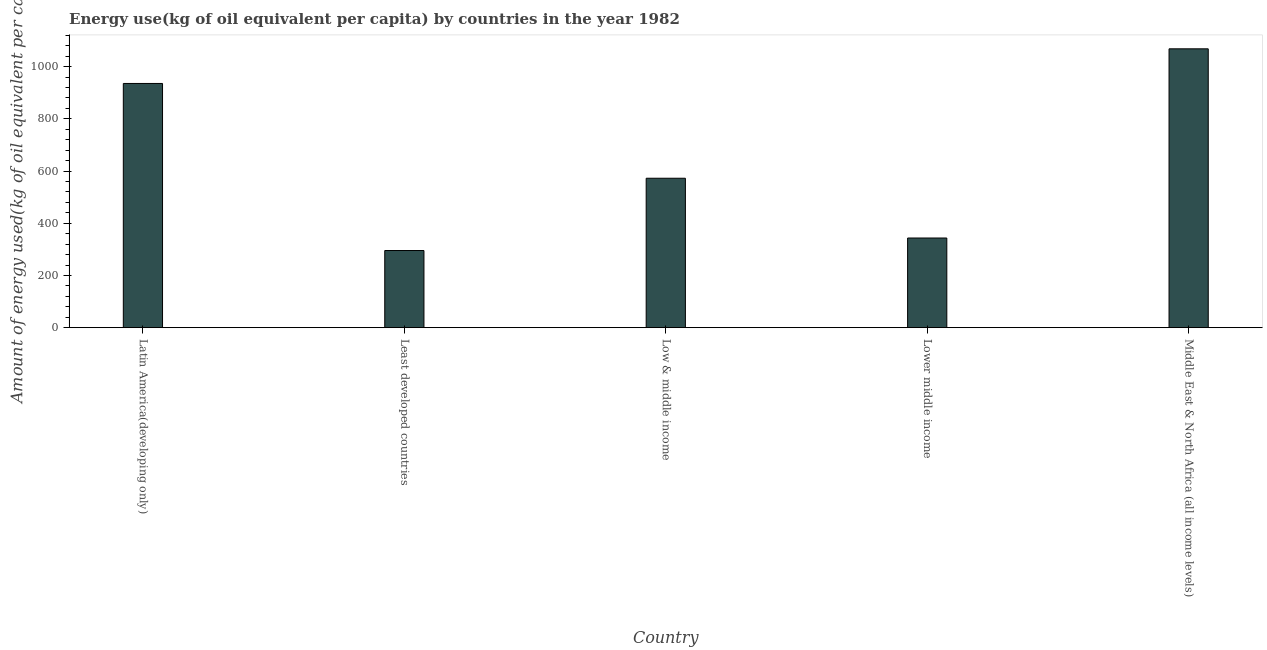Does the graph contain any zero values?
Keep it short and to the point. No. Does the graph contain grids?
Your answer should be very brief. No. What is the title of the graph?
Provide a short and direct response. Energy use(kg of oil equivalent per capita) by countries in the year 1982. What is the label or title of the Y-axis?
Provide a succinct answer. Amount of energy used(kg of oil equivalent per capita). What is the amount of energy used in Lower middle income?
Offer a terse response. 343.55. Across all countries, what is the maximum amount of energy used?
Make the answer very short. 1068.44. Across all countries, what is the minimum amount of energy used?
Provide a short and direct response. 295.55. In which country was the amount of energy used maximum?
Offer a very short reply. Middle East & North Africa (all income levels). In which country was the amount of energy used minimum?
Make the answer very short. Least developed countries. What is the sum of the amount of energy used?
Your answer should be compact. 3215.76. What is the difference between the amount of energy used in Low & middle income and Middle East & North Africa (all income levels)?
Your answer should be very brief. -495.9. What is the average amount of energy used per country?
Provide a succinct answer. 643.15. What is the median amount of energy used?
Offer a terse response. 572.54. What is the ratio of the amount of energy used in Lower middle income to that in Middle East & North Africa (all income levels)?
Provide a succinct answer. 0.32. Is the difference between the amount of energy used in Least developed countries and Middle East & North Africa (all income levels) greater than the difference between any two countries?
Make the answer very short. Yes. What is the difference between the highest and the second highest amount of energy used?
Your answer should be very brief. 132.76. Is the sum of the amount of energy used in Low & middle income and Middle East & North Africa (all income levels) greater than the maximum amount of energy used across all countries?
Ensure brevity in your answer.  Yes. What is the difference between the highest and the lowest amount of energy used?
Your response must be concise. 772.89. In how many countries, is the amount of energy used greater than the average amount of energy used taken over all countries?
Offer a terse response. 2. How many bars are there?
Make the answer very short. 5. What is the Amount of energy used(kg of oil equivalent per capita) in Latin America(developing only)?
Give a very brief answer. 935.68. What is the Amount of energy used(kg of oil equivalent per capita) in Least developed countries?
Your response must be concise. 295.55. What is the Amount of energy used(kg of oil equivalent per capita) of Low & middle income?
Offer a terse response. 572.54. What is the Amount of energy used(kg of oil equivalent per capita) in Lower middle income?
Provide a succinct answer. 343.55. What is the Amount of energy used(kg of oil equivalent per capita) in Middle East & North Africa (all income levels)?
Give a very brief answer. 1068.44. What is the difference between the Amount of energy used(kg of oil equivalent per capita) in Latin America(developing only) and Least developed countries?
Provide a short and direct response. 640.13. What is the difference between the Amount of energy used(kg of oil equivalent per capita) in Latin America(developing only) and Low & middle income?
Your response must be concise. 363.14. What is the difference between the Amount of energy used(kg of oil equivalent per capita) in Latin America(developing only) and Lower middle income?
Keep it short and to the point. 592.12. What is the difference between the Amount of energy used(kg of oil equivalent per capita) in Latin America(developing only) and Middle East & North Africa (all income levels)?
Offer a very short reply. -132.76. What is the difference between the Amount of energy used(kg of oil equivalent per capita) in Least developed countries and Low & middle income?
Keep it short and to the point. -276.99. What is the difference between the Amount of energy used(kg of oil equivalent per capita) in Least developed countries and Lower middle income?
Give a very brief answer. -48. What is the difference between the Amount of energy used(kg of oil equivalent per capita) in Least developed countries and Middle East & North Africa (all income levels)?
Provide a short and direct response. -772.89. What is the difference between the Amount of energy used(kg of oil equivalent per capita) in Low & middle income and Lower middle income?
Provide a succinct answer. 228.98. What is the difference between the Amount of energy used(kg of oil equivalent per capita) in Low & middle income and Middle East & North Africa (all income levels)?
Provide a short and direct response. -495.9. What is the difference between the Amount of energy used(kg of oil equivalent per capita) in Lower middle income and Middle East & North Africa (all income levels)?
Your answer should be compact. -724.88. What is the ratio of the Amount of energy used(kg of oil equivalent per capita) in Latin America(developing only) to that in Least developed countries?
Offer a terse response. 3.17. What is the ratio of the Amount of energy used(kg of oil equivalent per capita) in Latin America(developing only) to that in Low & middle income?
Give a very brief answer. 1.63. What is the ratio of the Amount of energy used(kg of oil equivalent per capita) in Latin America(developing only) to that in Lower middle income?
Your answer should be very brief. 2.72. What is the ratio of the Amount of energy used(kg of oil equivalent per capita) in Latin America(developing only) to that in Middle East & North Africa (all income levels)?
Your response must be concise. 0.88. What is the ratio of the Amount of energy used(kg of oil equivalent per capita) in Least developed countries to that in Low & middle income?
Ensure brevity in your answer.  0.52. What is the ratio of the Amount of energy used(kg of oil equivalent per capita) in Least developed countries to that in Lower middle income?
Make the answer very short. 0.86. What is the ratio of the Amount of energy used(kg of oil equivalent per capita) in Least developed countries to that in Middle East & North Africa (all income levels)?
Your response must be concise. 0.28. What is the ratio of the Amount of energy used(kg of oil equivalent per capita) in Low & middle income to that in Lower middle income?
Provide a short and direct response. 1.67. What is the ratio of the Amount of energy used(kg of oil equivalent per capita) in Low & middle income to that in Middle East & North Africa (all income levels)?
Ensure brevity in your answer.  0.54. What is the ratio of the Amount of energy used(kg of oil equivalent per capita) in Lower middle income to that in Middle East & North Africa (all income levels)?
Keep it short and to the point. 0.32. 